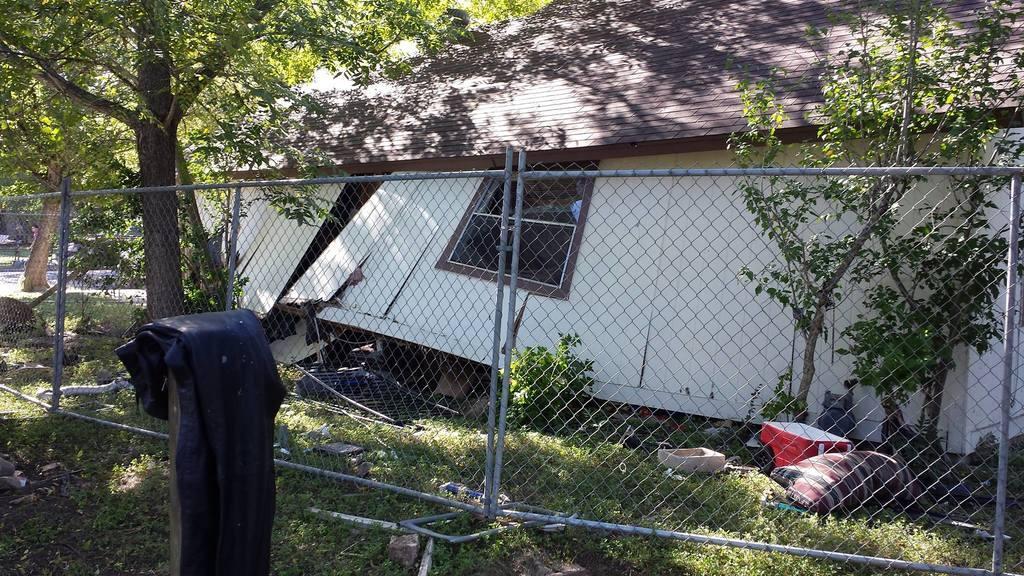Can you describe this image briefly? In this image, we can see the fence, there's a house, we can see some plants and trees, there's grass on the ground, we can see the red color box on the grass. 